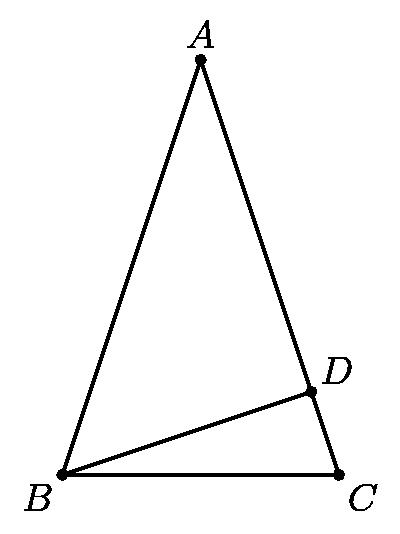Can you explain why the triangle ABC must be isosceles, and why BD is perpendicular to AC? In the given configuration, triangle ABC is isosceles because AB equals AC, a specification of the problem. This equality gives the triangle symmetry. The line segment BD is perpendicular to AC because it's stated so in the problem conditions, meaning BD forms a right angle with line AC, making triangle ADB a right triangle. This setup establishes specific geometric properties important for further solutions. 